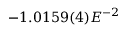<formula> <loc_0><loc_0><loc_500><loc_500>- 1 . 0 1 5 9 ( 4 ) E ^ { - 2 }</formula> 